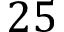<formula> <loc_0><loc_0><loc_500><loc_500>2 5</formula> 